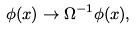Convert formula to latex. <formula><loc_0><loc_0><loc_500><loc_500>\phi ( x ) \rightarrow \Omega ^ { - 1 } \phi ( x ) ,</formula> 